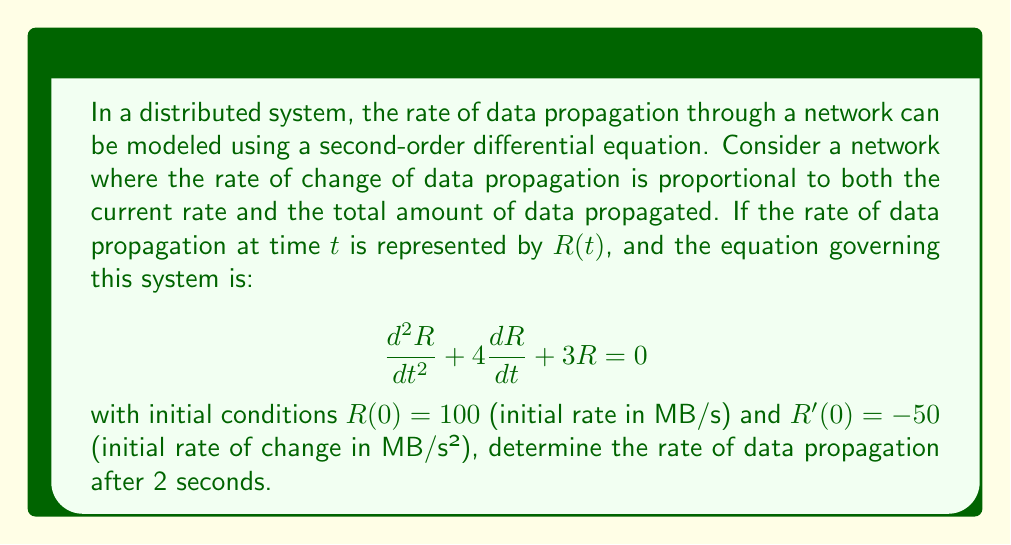Can you answer this question? To solve this problem, we need to follow these steps:

1) First, we recognize this as a homogeneous second-order linear differential equation with constant coefficients. The characteristic equation is:

   $$r^2 + 4r + 3 = 0$$

2) Solve the characteristic equation:
   $$(r + 1)(r + 3) = 0$$
   $$r = -1 \text{ or } r = -3$$

3) The general solution is therefore:

   $$R(t) = c_1e^{-t} + c_2e^{-3t}$$

4) To find $c_1$ and $c_2$, we use the initial conditions:

   $R(0) = 100$: $c_1 + c_2 = 100$
   $R'(0) = -50$: $-c_1 - 3c_2 = -50$

5) Solving these equations:
   $c_1 = 75$ and $c_2 = 25$

6) Therefore, the particular solution is:

   $$R(t) = 75e^{-t} + 25e^{-3t}$$

7) To find the rate after 2 seconds, we evaluate $R(2)$:

   $$R(2) = 75e^{-2} + 25e^{-6}$$

8) Calculating this value:
   $$R(2) \approx 10.14 \text{ MB/s}$$
Answer: The rate of data propagation after 2 seconds is approximately 10.14 MB/s. 